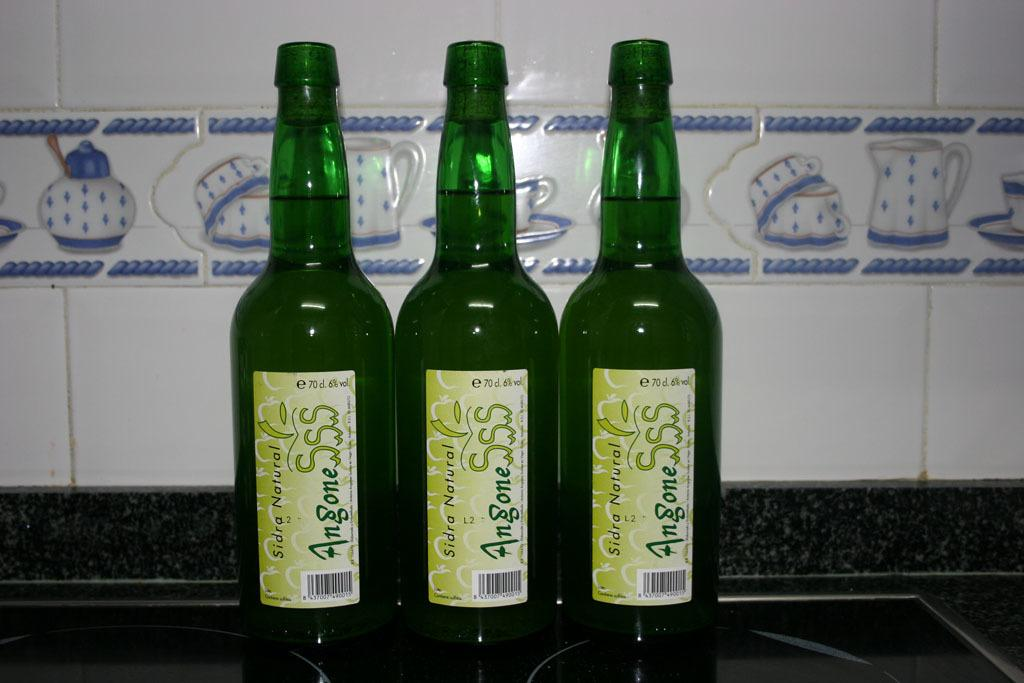<image>
Relay a brief, clear account of the picture shown. Three green bottles next to each other that say Sidra Natural 